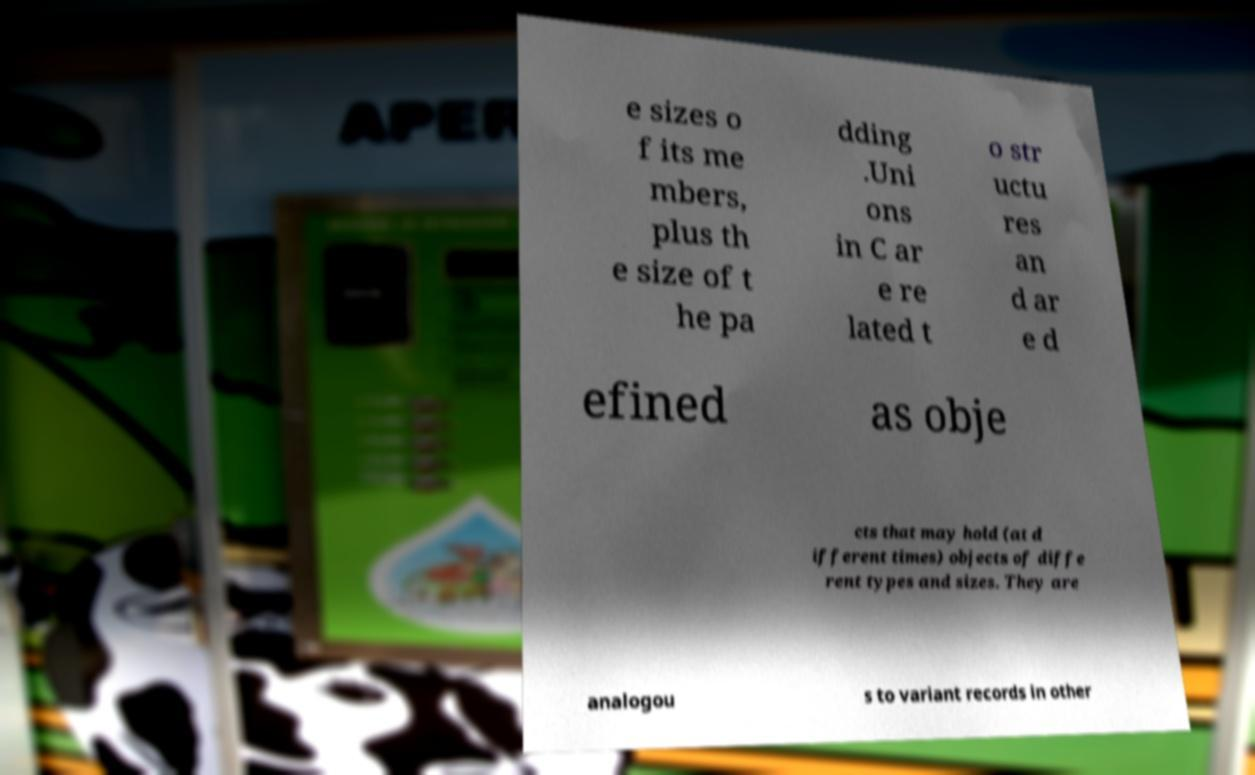There's text embedded in this image that I need extracted. Can you transcribe it verbatim? e sizes o f its me mbers, plus th e size of t he pa dding .Uni ons in C ar e re lated t o str uctu res an d ar e d efined as obje cts that may hold (at d ifferent times) objects of diffe rent types and sizes. They are analogou s to variant records in other 